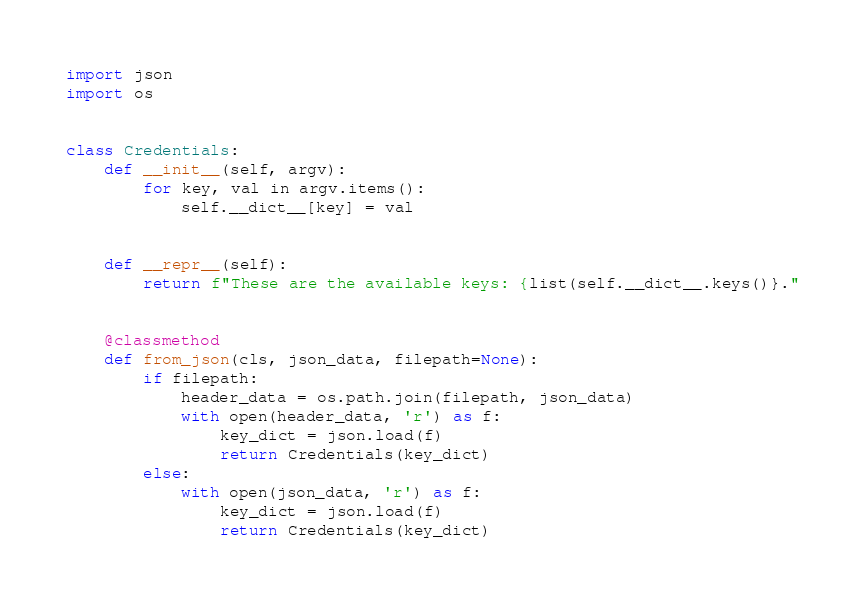<code> <loc_0><loc_0><loc_500><loc_500><_Python_>import json
import os


class Credentials:
    def __init__(self, argv):
        for key, val in argv.items():
            self.__dict__[key] = val


    def __repr__(self):
        return f"These are the available keys: {list(self.__dict__.keys()}."


    @classmethod
    def from_json(cls, json_data, filepath=None):
        if filepath:
            header_data = os.path.join(filepath, json_data)
            with open(header_data, 'r') as f:
                key_dict = json.load(f)
                return Credentials(key_dict)
        else:
            with open(json_data, 'r') as f:
                key_dict = json.load(f)
                return Credentials(key_dict)
</code> 